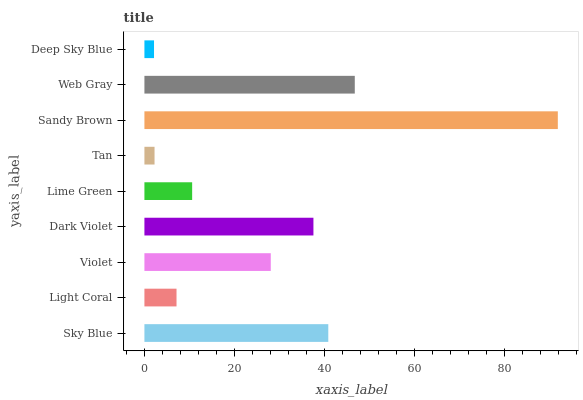Is Deep Sky Blue the minimum?
Answer yes or no. Yes. Is Sandy Brown the maximum?
Answer yes or no. Yes. Is Light Coral the minimum?
Answer yes or no. No. Is Light Coral the maximum?
Answer yes or no. No. Is Sky Blue greater than Light Coral?
Answer yes or no. Yes. Is Light Coral less than Sky Blue?
Answer yes or no. Yes. Is Light Coral greater than Sky Blue?
Answer yes or no. No. Is Sky Blue less than Light Coral?
Answer yes or no. No. Is Violet the high median?
Answer yes or no. Yes. Is Violet the low median?
Answer yes or no. Yes. Is Deep Sky Blue the high median?
Answer yes or no. No. Is Light Coral the low median?
Answer yes or no. No. 